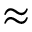Convert formula to latex. <formula><loc_0><loc_0><loc_500><loc_500>\approx</formula> 